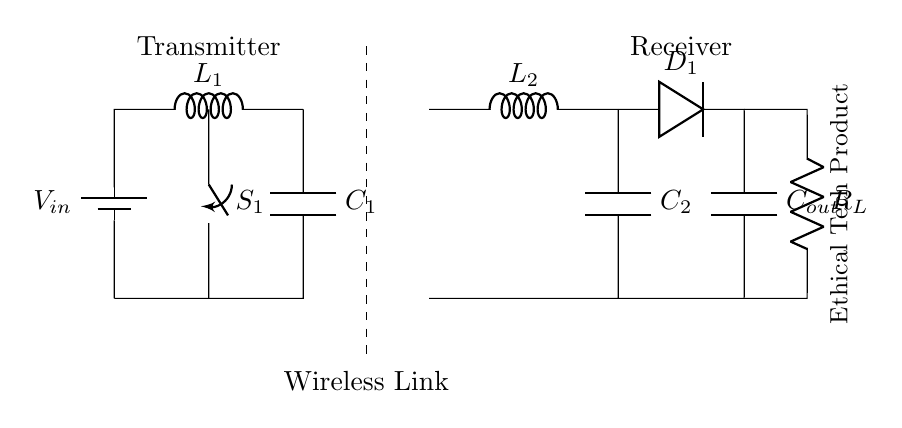What is the input voltage for the transmitter? The input voltage is represented by the symbol V_in located at the battery in the diagram, which sources the power to the circuit.
Answer: V_in What is the purpose of the switch S1? The switch S1 is used to control the flow of current in the transmitter section; when closed, it allows power to flow from the battery to the rest of the circuit.
Answer: Control current What components are involved in the wireless power transfer? The dashed line indicates the wireless link, which is the mechanism used for transferring energy wirelessly between the transmitter and receiver.
Answer: Wireless link How many capacitors are there in the entire circuit? There are three capacitors: C1 and C2 on the transmitter and receiver sides, respectively, and C_out at the receiver output, totaling three.
Answer: Three What type of load does R_L represent? R_L is the load resistor, which represents the device or application that is consuming the power delivered to it from the wireless power transfer, designed to suit low power appliances.
Answer: Load resistor What is the role of the inductors in the circuit? The inductors L1 and L2 are part of the resonant circuits that facilitate energy transfer between the transmitter and receiver, playing a key role in achieving efficient wireless power transfer.
Answer: Energy transfer 